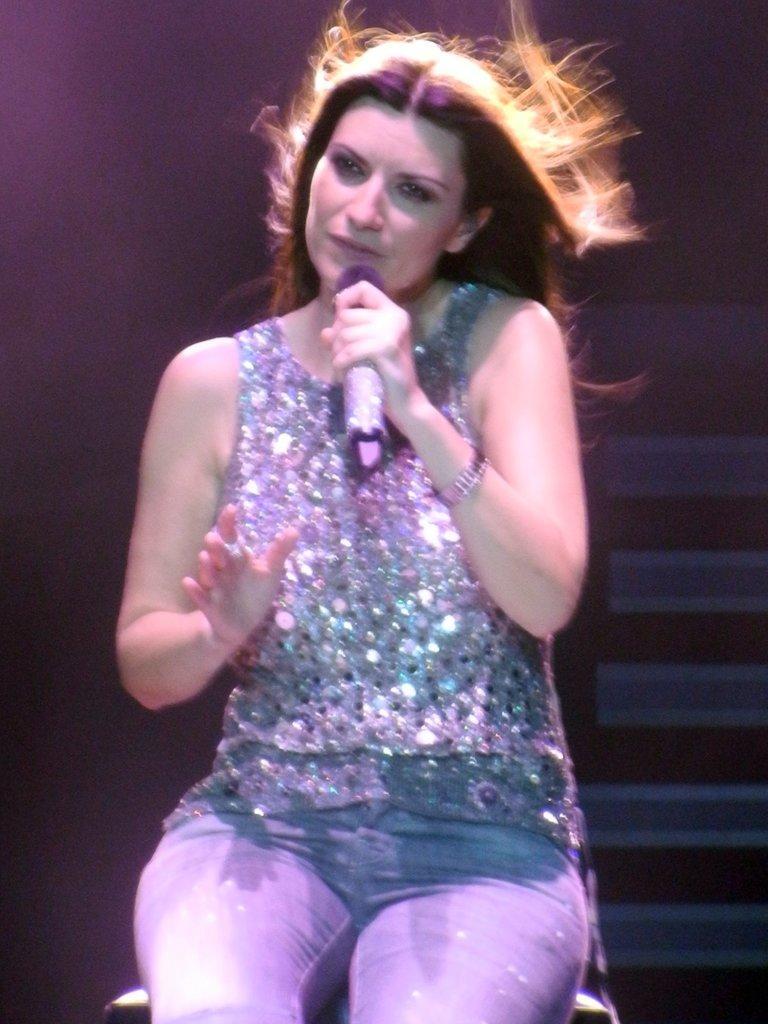Please provide a concise description of this image. In the middle of the image a woman is sitting and holding a microphone. 